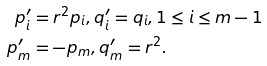Convert formula to latex. <formula><loc_0><loc_0><loc_500><loc_500>p _ { i } ^ { \prime } & = r ^ { 2 } p _ { i } , q _ { i } ^ { \prime } = q _ { i } , 1 \leq i \leq m - 1 \\ p _ { m } ^ { \prime } & = - p _ { m } , q _ { m } ^ { \prime } = r ^ { 2 } .</formula> 